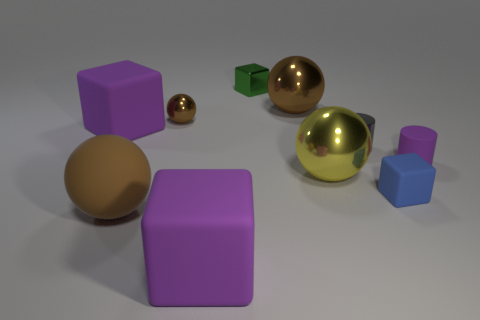What number of other objects are the same size as the rubber sphere?
Your answer should be very brief. 4. There is a tiny sphere; does it have the same color as the large object that is behind the small brown shiny ball?
Provide a short and direct response. Yes. Is the number of big rubber things behind the big brown shiny ball less than the number of small cylinders that are in front of the yellow shiny thing?
Keep it short and to the point. No. The rubber thing that is both to the left of the big yellow thing and behind the large brown rubber object is what color?
Offer a very short reply. Purple. There is a brown matte sphere; is its size the same as the purple rubber cube that is right of the large brown matte sphere?
Make the answer very short. Yes. There is a small metal object on the right side of the green shiny object; what is its shape?
Give a very brief answer. Cylinder. Are there any other things that have the same material as the gray cylinder?
Offer a terse response. Yes. Is the number of large yellow metallic objects to the left of the big yellow object greater than the number of small gray cylinders?
Your answer should be compact. No. There is a purple cube that is right of the big brown object that is left of the small green metallic cube; how many brown matte objects are to the right of it?
Your answer should be compact. 0. Does the metal sphere that is left of the large brown shiny ball have the same size as the brown rubber object to the left of the green thing?
Provide a succinct answer. No. 